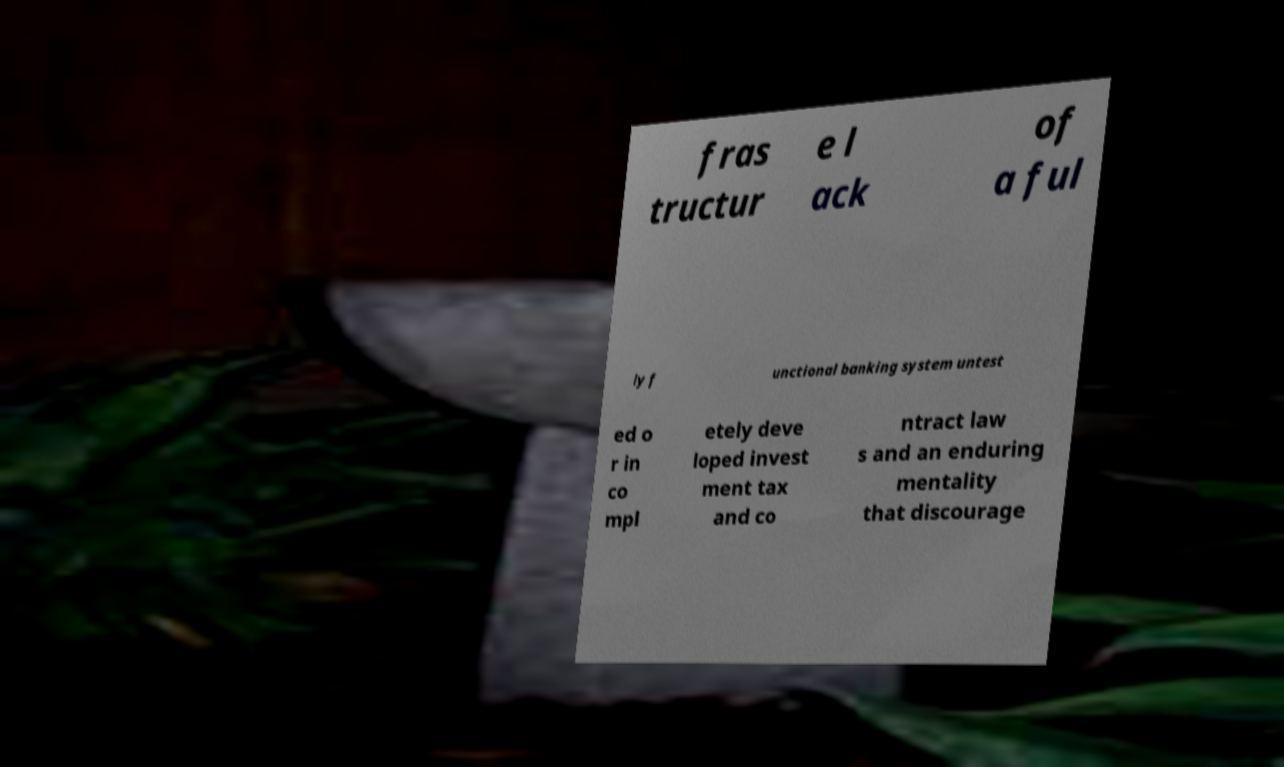Please read and relay the text visible in this image. What does it say? fras tructur e l ack of a ful ly f unctional banking system untest ed o r in co mpl etely deve loped invest ment tax and co ntract law s and an enduring mentality that discourage 